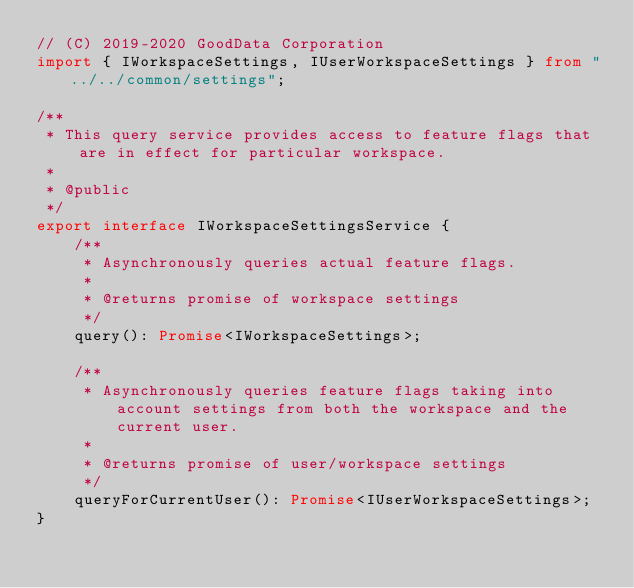Convert code to text. <code><loc_0><loc_0><loc_500><loc_500><_TypeScript_>// (C) 2019-2020 GoodData Corporation
import { IWorkspaceSettings, IUserWorkspaceSettings } from "../../common/settings";

/**
 * This query service provides access to feature flags that are in effect for particular workspace.
 *
 * @public
 */
export interface IWorkspaceSettingsService {
    /**
     * Asynchronously queries actual feature flags.
     *
     * @returns promise of workspace settings
     */
    query(): Promise<IWorkspaceSettings>;

    /**
     * Asynchronously queries feature flags taking into account settings from both the workspace and the current user.
     *
     * @returns promise of user/workspace settings
     */
    queryForCurrentUser(): Promise<IUserWorkspaceSettings>;
}
</code> 